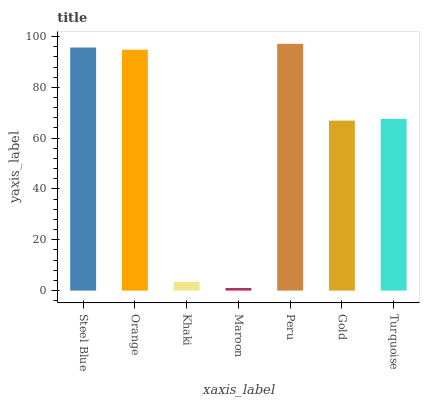Is Maroon the minimum?
Answer yes or no. Yes. Is Peru the maximum?
Answer yes or no. Yes. Is Orange the minimum?
Answer yes or no. No. Is Orange the maximum?
Answer yes or no. No. Is Steel Blue greater than Orange?
Answer yes or no. Yes. Is Orange less than Steel Blue?
Answer yes or no. Yes. Is Orange greater than Steel Blue?
Answer yes or no. No. Is Steel Blue less than Orange?
Answer yes or no. No. Is Turquoise the high median?
Answer yes or no. Yes. Is Turquoise the low median?
Answer yes or no. Yes. Is Khaki the high median?
Answer yes or no. No. Is Maroon the low median?
Answer yes or no. No. 